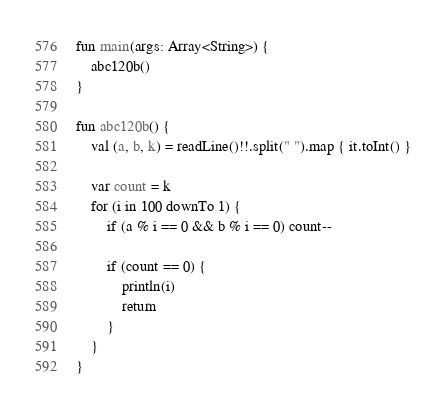<code> <loc_0><loc_0><loc_500><loc_500><_Kotlin_>fun main(args: Array<String>) {
    abc120b()
}

fun abc120b() {
    val (a, b, k) = readLine()!!.split(" ").map { it.toInt() }

    var count = k
    for (i in 100 downTo 1) {
        if (a % i == 0 && b % i == 0) count--

        if (count == 0) {
            println(i)
            return
        }
    }
}
</code> 